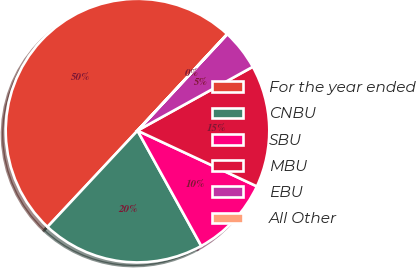<chart> <loc_0><loc_0><loc_500><loc_500><pie_chart><fcel>For the year ended<fcel>CNBU<fcel>SBU<fcel>MBU<fcel>EBU<fcel>All Other<nl><fcel>49.95%<fcel>20.0%<fcel>10.01%<fcel>15.0%<fcel>5.02%<fcel>0.02%<nl></chart> 